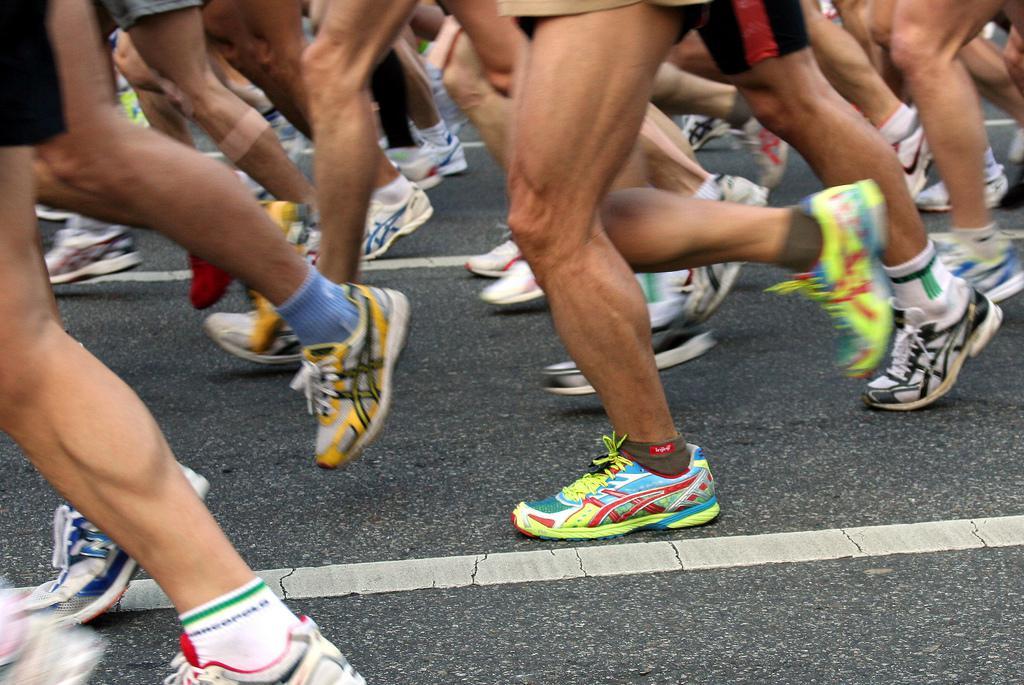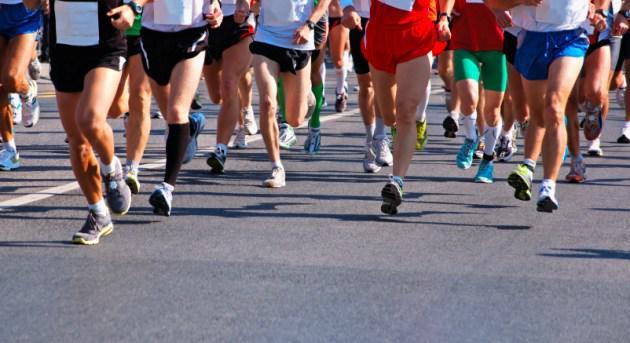The first image is the image on the left, the second image is the image on the right. Analyze the images presented: Is the assertion "There are two shoes in the left image" valid? Answer yes or no. No. The first image is the image on the left, the second image is the image on the right. Assess this claim about the two images: "The feet and legs of many people running in a race are shown.". Correct or not? Answer yes or no. Yes. 